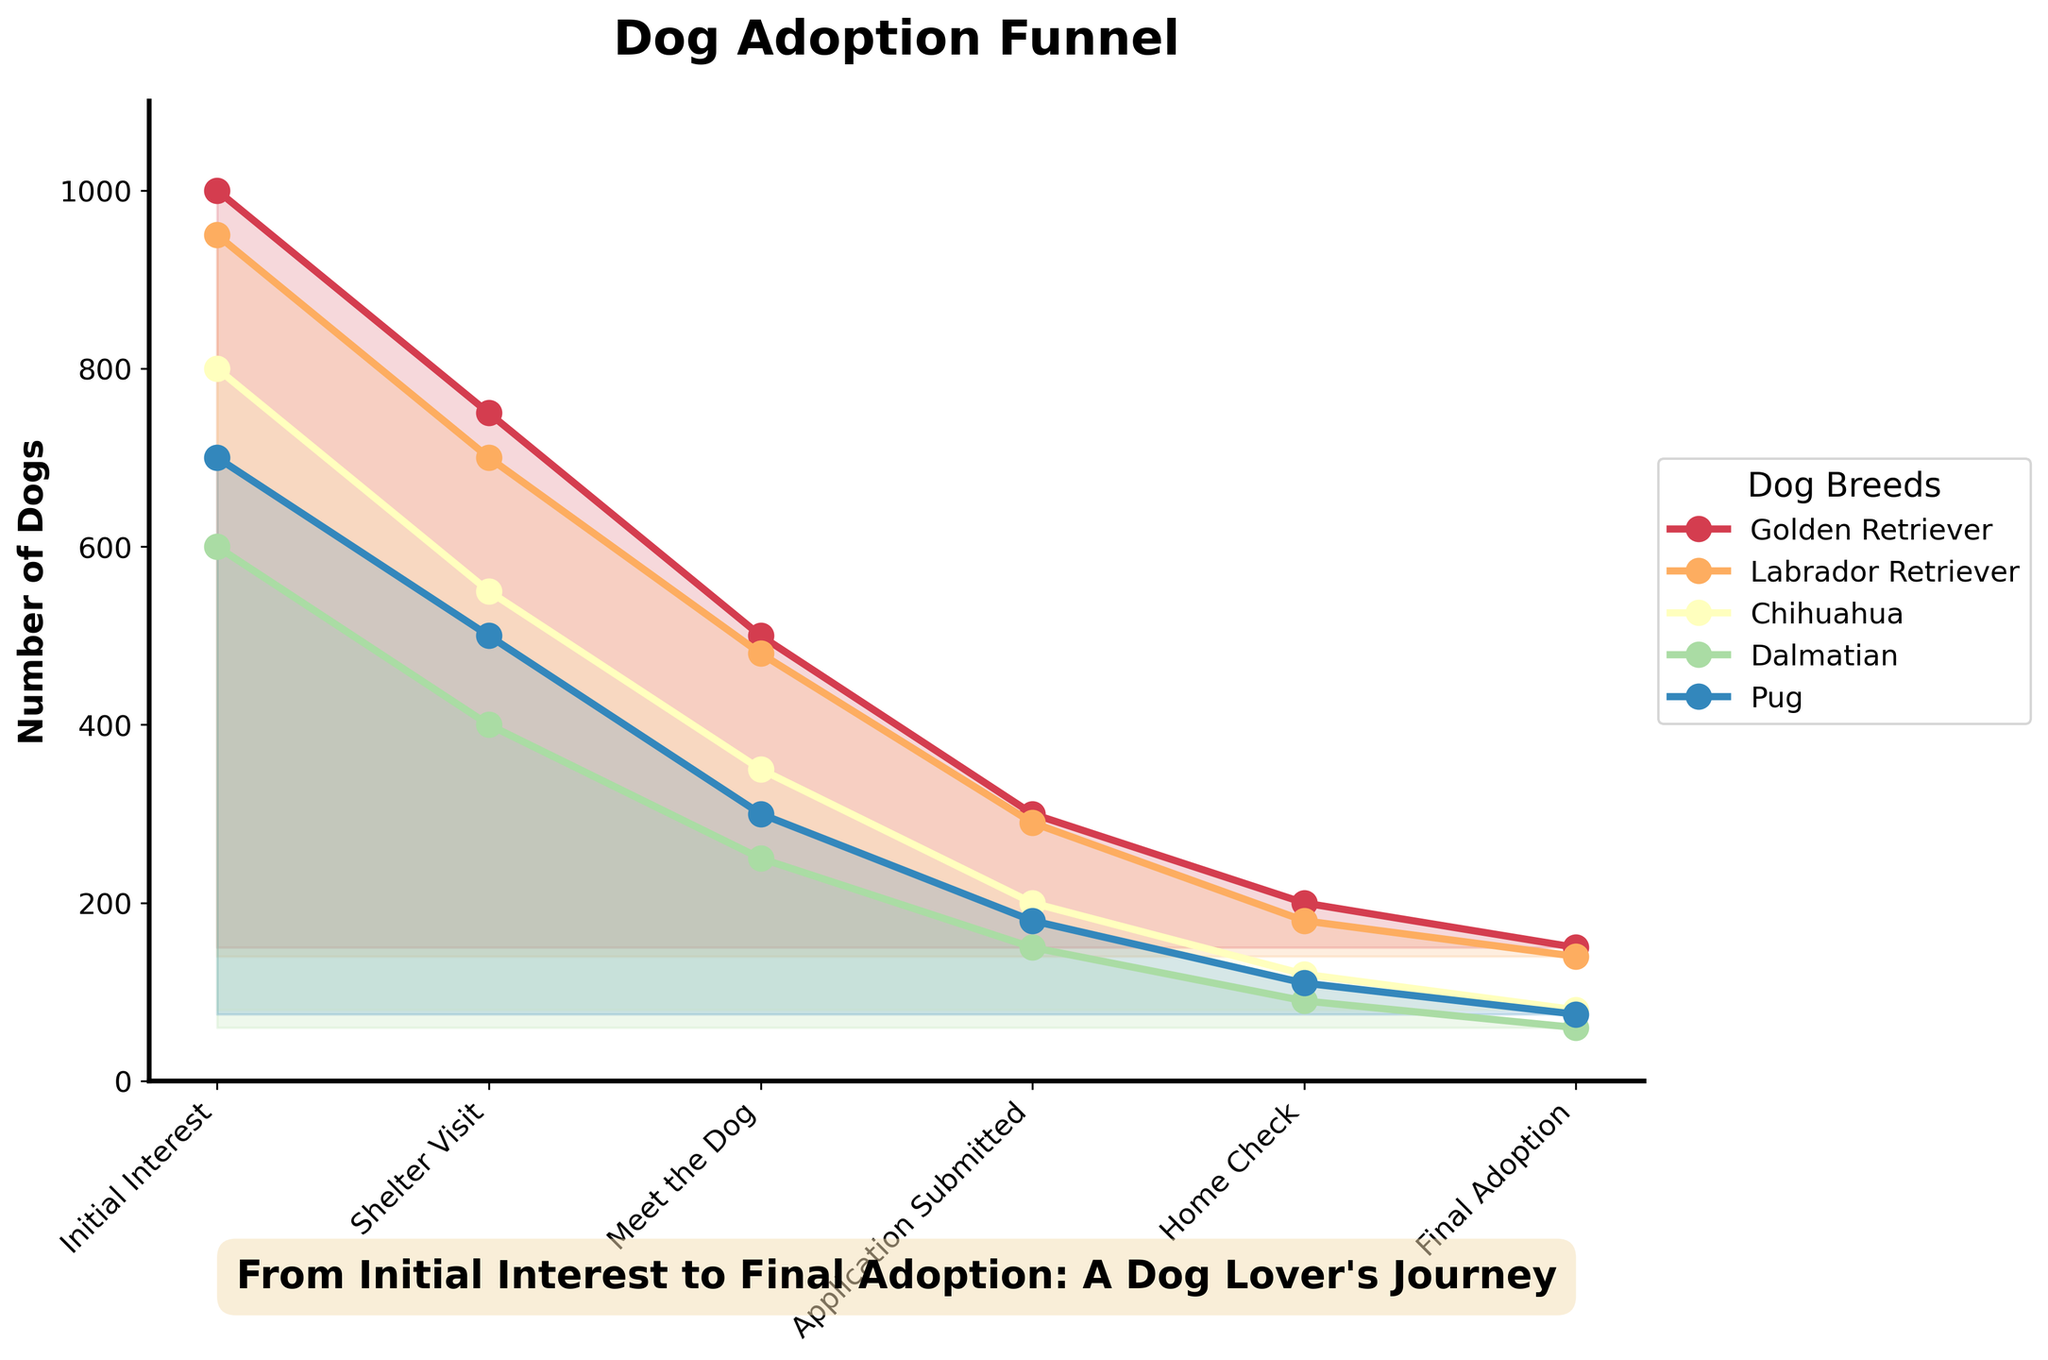What is the title of the figure? The title is usually positioned at the top center of the figure and is often in bold text. Here, it indicates the main subject of the chart.
Answer: Dog Adoption Funnel How many stages are there in the funnel? The stages of a funnel chart are listed along the horizontal axis. By counting the labels, the number of stages can be determined.
Answer: 6 At which stage does the largest drop in numbers occur for Golden Retrievers? By observing the plot line of Golden Retrievers, determine the stage where the number decreases the most between two consecutive points.
Answer: Meet the Dog to Application Submitted Which dog breed has the highest final adoption rate? By looking at the final points of all plot lines, identify which breed corresponds to the highest value.
Answer: Golden Retriever Compare the number of Pugs in the 'Shelter Visit' stage to Dalmatians in the 'Meet the Dog' stage. Which breed has more? Locate the values for Pugs at the 'Shelter Visit' stage and Dalmatians at the 'Meet the Dog' stage. Compare the two numbers directly.
Answer: Pug What is the average number of applications submitted across all breeds? Sum the values at the 'Application Submitted' stage for all breeds and then divide by the number of breeds. (300 + 290 + 200 + 150 + 180) / 5 = 224
Answer: 224 Which stage shows the most significant overall drop in dog numbers from the previous stage? For each transition between two stages, sum the differences across all breeds and identify the largest combined drop.
Answer: Application Submitted to Home Check What is the ratio of Chihuahuas that reach the 'Home Check' stage to those that expressed Initial Interest? Divide the number of Chihuahuas at the 'Home Check' stage by those at the 'Initial Interest' stage. 120 / 800 = 0.15
Answer: 0.15 Is there any breed that has the same number of 'Final Adoptions' and 'Home Checks'? Check each breed's numbers at 'Home Check' and 'Final Adoption' stages to see if any match.
Answer: No 